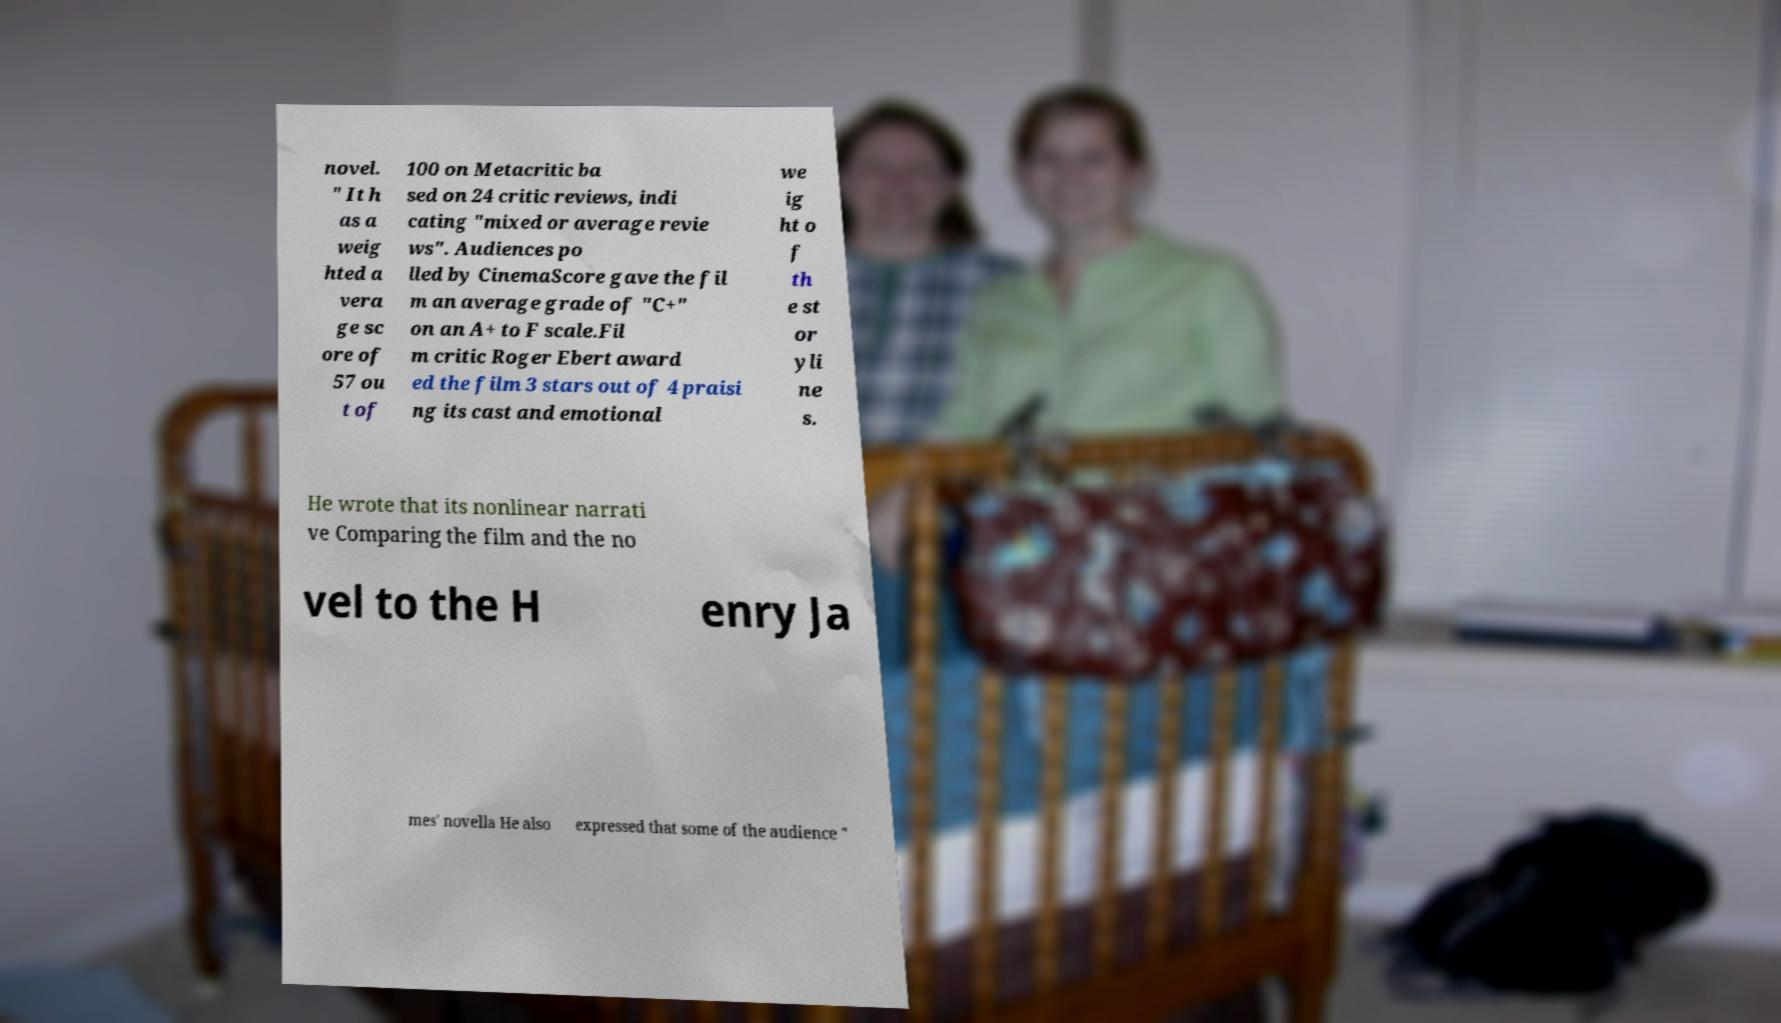I need the written content from this picture converted into text. Can you do that? novel. " It h as a weig hted a vera ge sc ore of 57 ou t of 100 on Metacritic ba sed on 24 critic reviews, indi cating "mixed or average revie ws". Audiences po lled by CinemaScore gave the fil m an average grade of "C+" on an A+ to F scale.Fil m critic Roger Ebert award ed the film 3 stars out of 4 praisi ng its cast and emotional we ig ht o f th e st or yli ne s. He wrote that its nonlinear narrati ve Comparing the film and the no vel to the H enry Ja mes' novella He also expressed that some of the audience " 